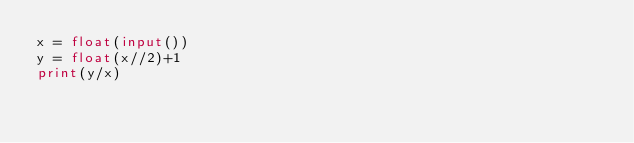Convert code to text. <code><loc_0><loc_0><loc_500><loc_500><_Python_>x = float(input())
y = float(x//2)+1
print(y/x)
</code> 